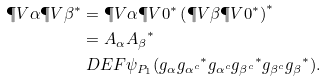<formula> <loc_0><loc_0><loc_500><loc_500>\P V { \alpha } \P V { \beta } ^ { * } & = \P V { \alpha } \P V { 0 } ^ { * } \left ( \P V { \beta } \P V { 0 } ^ { * } \right ) ^ { * } \\ & = A _ { \alpha } { A _ { \beta } } ^ { * } \\ & \ D E F \psi _ { P _ { 1 } } ( g _ { \alpha } { g _ { \alpha ^ { c } } } ^ { * } g _ { \alpha ^ { c } } { g _ { \beta ^ { c } } } ^ { * } g _ { \beta ^ { c } } { g _ { \beta } } ^ { * } ) .</formula> 